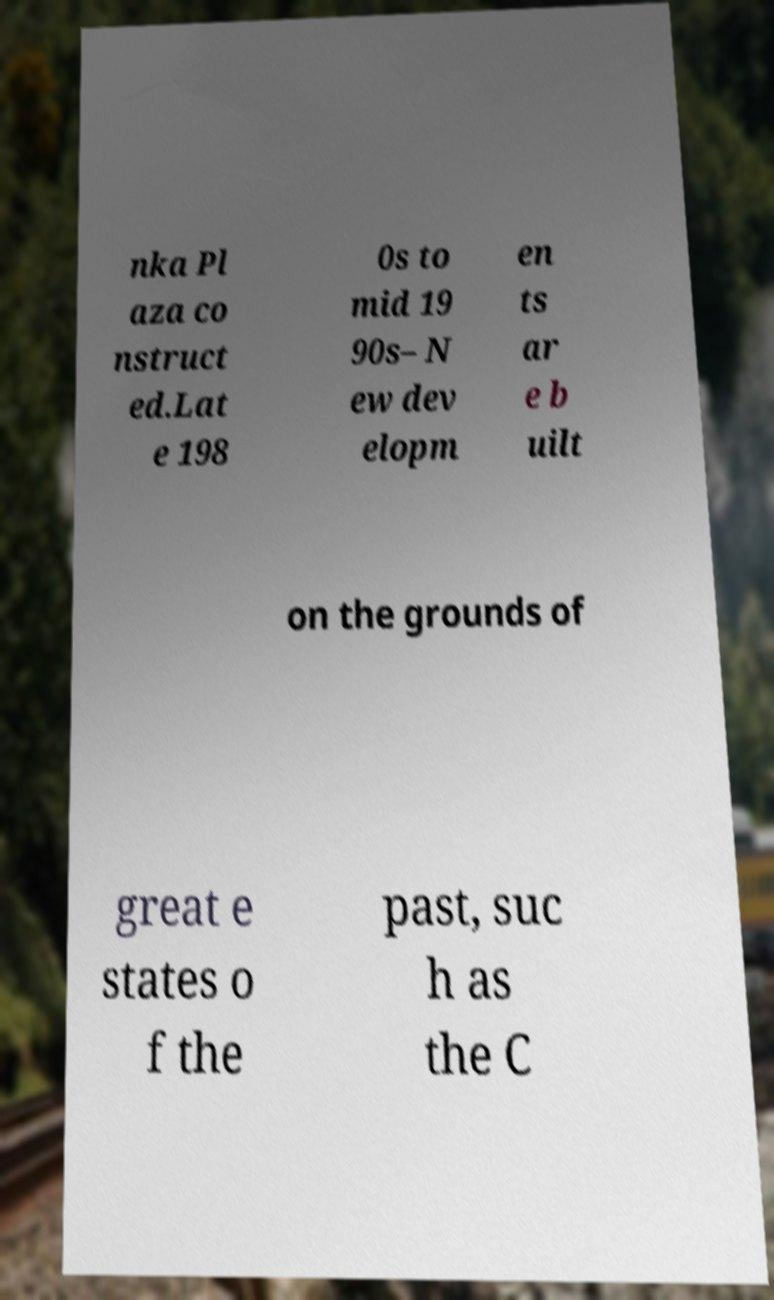I need the written content from this picture converted into text. Can you do that? nka Pl aza co nstruct ed.Lat e 198 0s to mid 19 90s– N ew dev elopm en ts ar e b uilt on the grounds of great e states o f the past, suc h as the C 